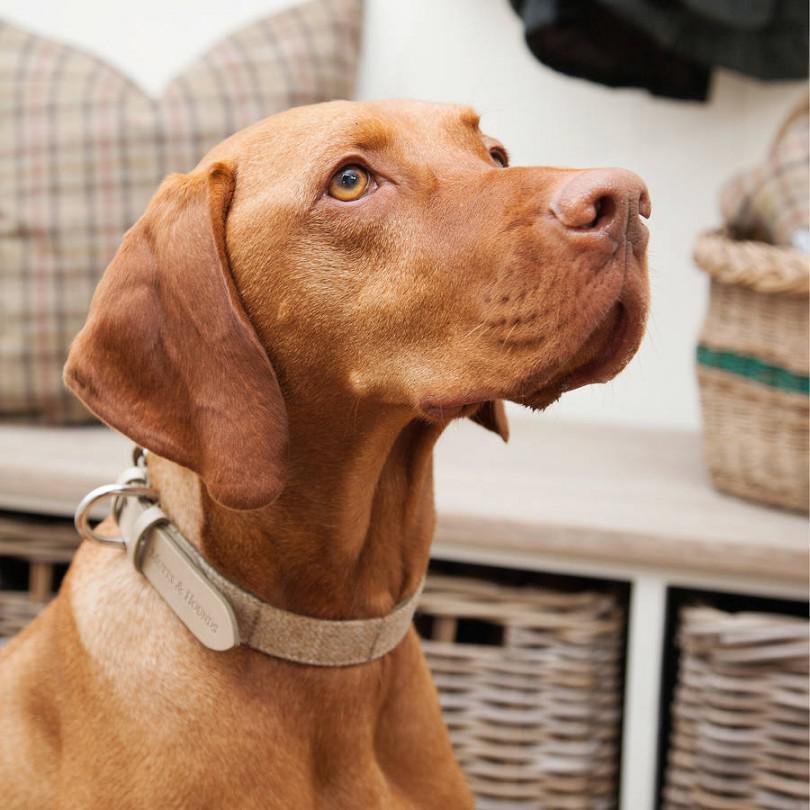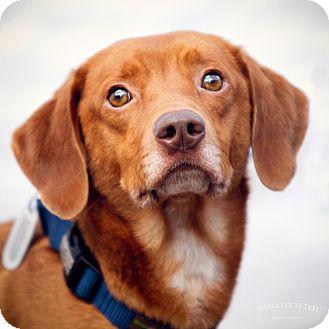The first image is the image on the left, the second image is the image on the right. Analyze the images presented: Is the assertion "One dog faces straight ahead, at least one dog is wearing a blue collar, and at least two dogs are wearing collars." valid? Answer yes or no. Yes. The first image is the image on the left, the second image is the image on the right. For the images shown, is this caption "There are exactly two dogs." true? Answer yes or no. Yes. 